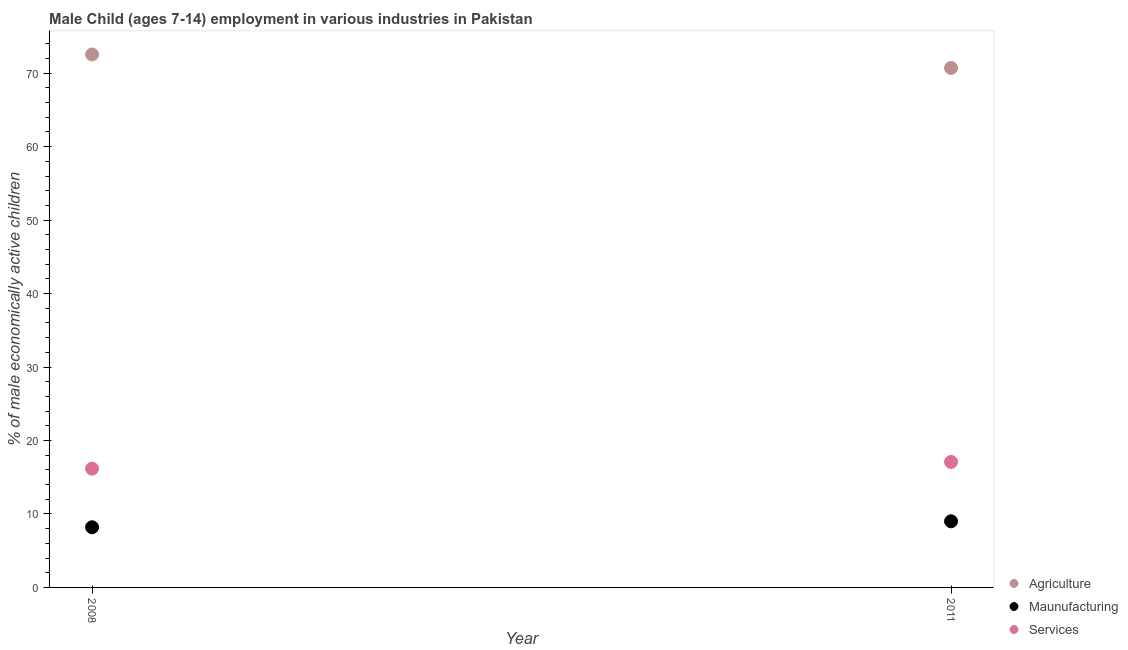What is the percentage of economically active children in agriculture in 2011?
Provide a succinct answer. 70.72. Across all years, what is the maximum percentage of economically active children in manufacturing?
Your answer should be very brief. 9. Across all years, what is the minimum percentage of economically active children in manufacturing?
Your answer should be very brief. 8.19. What is the total percentage of economically active children in manufacturing in the graph?
Offer a terse response. 17.19. What is the difference between the percentage of economically active children in manufacturing in 2008 and that in 2011?
Provide a succinct answer. -0.81. What is the difference between the percentage of economically active children in manufacturing in 2011 and the percentage of economically active children in agriculture in 2008?
Keep it short and to the point. -63.55. What is the average percentage of economically active children in manufacturing per year?
Provide a short and direct response. 8.59. In the year 2008, what is the difference between the percentage of economically active children in services and percentage of economically active children in agriculture?
Keep it short and to the point. -56.38. What is the ratio of the percentage of economically active children in manufacturing in 2008 to that in 2011?
Provide a short and direct response. 0.91. Is the percentage of economically active children in manufacturing in 2008 less than that in 2011?
Offer a very short reply. Yes. In how many years, is the percentage of economically active children in services greater than the average percentage of economically active children in services taken over all years?
Your answer should be compact. 1. Is it the case that in every year, the sum of the percentage of economically active children in agriculture and percentage of economically active children in manufacturing is greater than the percentage of economically active children in services?
Offer a terse response. Yes. How many dotlines are there?
Offer a very short reply. 3. What is the difference between two consecutive major ticks on the Y-axis?
Offer a terse response. 10. Are the values on the major ticks of Y-axis written in scientific E-notation?
Make the answer very short. No. How many legend labels are there?
Offer a terse response. 3. What is the title of the graph?
Ensure brevity in your answer.  Male Child (ages 7-14) employment in various industries in Pakistan. What is the label or title of the X-axis?
Offer a very short reply. Year. What is the label or title of the Y-axis?
Make the answer very short. % of male economically active children. What is the % of male economically active children of Agriculture in 2008?
Keep it short and to the point. 72.55. What is the % of male economically active children in Maunufacturing in 2008?
Give a very brief answer. 8.19. What is the % of male economically active children of Services in 2008?
Ensure brevity in your answer.  16.17. What is the % of male economically active children of Agriculture in 2011?
Your answer should be compact. 70.72. What is the % of male economically active children in Services in 2011?
Give a very brief answer. 17.08. Across all years, what is the maximum % of male economically active children of Agriculture?
Your response must be concise. 72.55. Across all years, what is the maximum % of male economically active children of Services?
Keep it short and to the point. 17.08. Across all years, what is the minimum % of male economically active children in Agriculture?
Provide a short and direct response. 70.72. Across all years, what is the minimum % of male economically active children of Maunufacturing?
Provide a short and direct response. 8.19. Across all years, what is the minimum % of male economically active children of Services?
Keep it short and to the point. 16.17. What is the total % of male economically active children of Agriculture in the graph?
Give a very brief answer. 143.27. What is the total % of male economically active children in Maunufacturing in the graph?
Provide a succinct answer. 17.19. What is the total % of male economically active children in Services in the graph?
Offer a very short reply. 33.25. What is the difference between the % of male economically active children in Agriculture in 2008 and that in 2011?
Your response must be concise. 1.83. What is the difference between the % of male economically active children in Maunufacturing in 2008 and that in 2011?
Offer a terse response. -0.81. What is the difference between the % of male economically active children in Services in 2008 and that in 2011?
Make the answer very short. -0.91. What is the difference between the % of male economically active children of Agriculture in 2008 and the % of male economically active children of Maunufacturing in 2011?
Provide a succinct answer. 63.55. What is the difference between the % of male economically active children in Agriculture in 2008 and the % of male economically active children in Services in 2011?
Your answer should be compact. 55.47. What is the difference between the % of male economically active children in Maunufacturing in 2008 and the % of male economically active children in Services in 2011?
Offer a terse response. -8.89. What is the average % of male economically active children of Agriculture per year?
Ensure brevity in your answer.  71.64. What is the average % of male economically active children in Maunufacturing per year?
Provide a short and direct response. 8.6. What is the average % of male economically active children of Services per year?
Ensure brevity in your answer.  16.62. In the year 2008, what is the difference between the % of male economically active children in Agriculture and % of male economically active children in Maunufacturing?
Provide a short and direct response. 64.36. In the year 2008, what is the difference between the % of male economically active children in Agriculture and % of male economically active children in Services?
Your answer should be compact. 56.38. In the year 2008, what is the difference between the % of male economically active children in Maunufacturing and % of male economically active children in Services?
Provide a succinct answer. -7.98. In the year 2011, what is the difference between the % of male economically active children in Agriculture and % of male economically active children in Maunufacturing?
Provide a short and direct response. 61.72. In the year 2011, what is the difference between the % of male economically active children of Agriculture and % of male economically active children of Services?
Provide a short and direct response. 53.64. In the year 2011, what is the difference between the % of male economically active children of Maunufacturing and % of male economically active children of Services?
Offer a terse response. -8.08. What is the ratio of the % of male economically active children of Agriculture in 2008 to that in 2011?
Ensure brevity in your answer.  1.03. What is the ratio of the % of male economically active children of Maunufacturing in 2008 to that in 2011?
Give a very brief answer. 0.91. What is the ratio of the % of male economically active children of Services in 2008 to that in 2011?
Give a very brief answer. 0.95. What is the difference between the highest and the second highest % of male economically active children in Agriculture?
Offer a terse response. 1.83. What is the difference between the highest and the second highest % of male economically active children in Maunufacturing?
Offer a very short reply. 0.81. What is the difference between the highest and the second highest % of male economically active children in Services?
Your answer should be compact. 0.91. What is the difference between the highest and the lowest % of male economically active children in Agriculture?
Your answer should be very brief. 1.83. What is the difference between the highest and the lowest % of male economically active children of Maunufacturing?
Your answer should be very brief. 0.81. What is the difference between the highest and the lowest % of male economically active children in Services?
Ensure brevity in your answer.  0.91. 